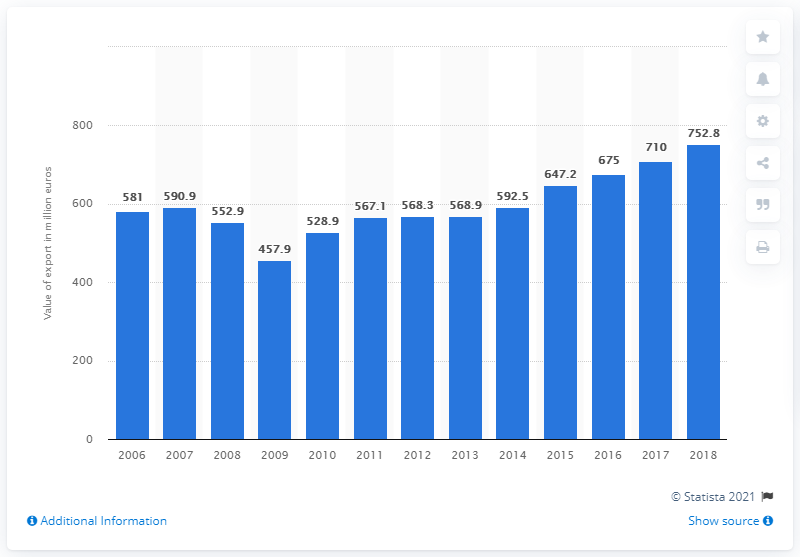Point out several critical features in this image. In 2006, the value of cork stoppers exported from Portugal was 581 million dollars. 